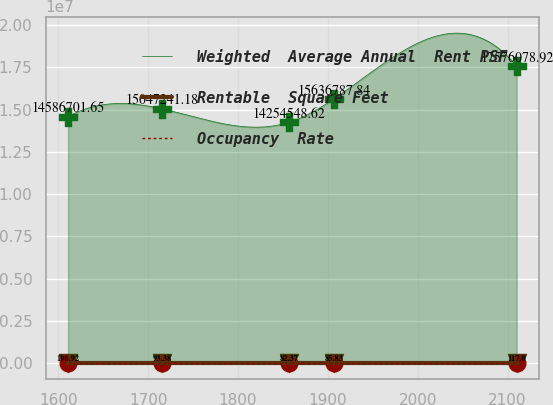<chart> <loc_0><loc_0><loc_500><loc_500><line_chart><ecel><fcel>Weighted  Average Annual  Rent PSF<fcel>Rentable  Square Feet<fcel>Occupancy  Rate<nl><fcel>1610.8<fcel>1.45867e+07<fcel>106.92<fcel>48.54<nl><fcel>1715.66<fcel>1.50472e+07<fcel>93.38<fcel>56.91<nl><fcel>1856.73<fcel>1.42545e+07<fcel>82.37<fcel>58.32<nl><fcel>1906.67<fcel>1.56368e+07<fcel>85.83<fcel>45.96<nl><fcel>2110.17<fcel>1.75761e+07<fcel>117<fcel>44.06<nl></chart> 